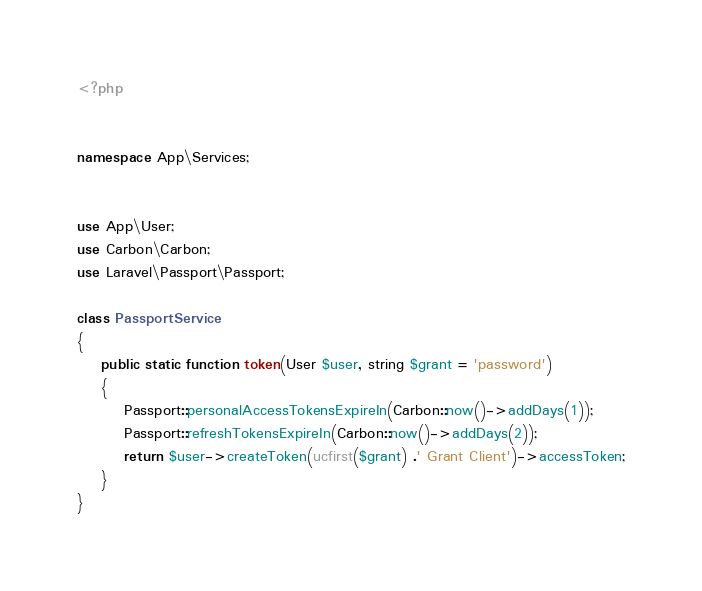Convert code to text. <code><loc_0><loc_0><loc_500><loc_500><_PHP_><?php


namespace App\Services;


use App\User;
use Carbon\Carbon;
use Laravel\Passport\Passport;

class PassportService
{
    public static function token(User $user, string $grant = 'password')
    {
        Passport::personalAccessTokensExpireIn(Carbon::now()->addDays(1));
        Passport::refreshTokensExpireIn(Carbon::now()->addDays(2));
        return $user->createToken(ucfirst($grant) .' Grant Client')->accessToken;
    }
}</code> 